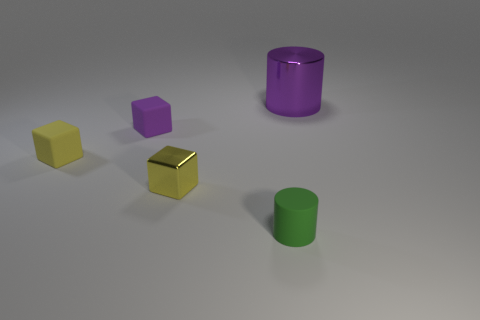There is a object that is the same color as the big metal cylinder; what shape is it?
Ensure brevity in your answer.  Cube. The metallic thing on the left side of the cylinder behind the tiny metallic cube is what color?
Ensure brevity in your answer.  Yellow. Is the number of green matte objects on the right side of the big purple shiny object the same as the number of tiny rubber cubes that are right of the tiny purple rubber block?
Provide a short and direct response. Yes. Is the material of the block on the right side of the purple cube the same as the small green cylinder?
Give a very brief answer. No. The small object that is behind the small matte cylinder and right of the small purple matte object is what color?
Your response must be concise. Yellow. What number of tiny green objects are left of the cylinder that is behind the small shiny thing?
Offer a very short reply. 1. There is a tiny thing that is the same shape as the big thing; what is it made of?
Keep it short and to the point. Rubber. What is the color of the large cylinder?
Provide a short and direct response. Purple. What number of things are either small yellow cubes or large things?
Offer a terse response. 3. There is a purple thing on the right side of the rubber thing that is in front of the small metal block; what is its shape?
Your answer should be compact. Cylinder. 